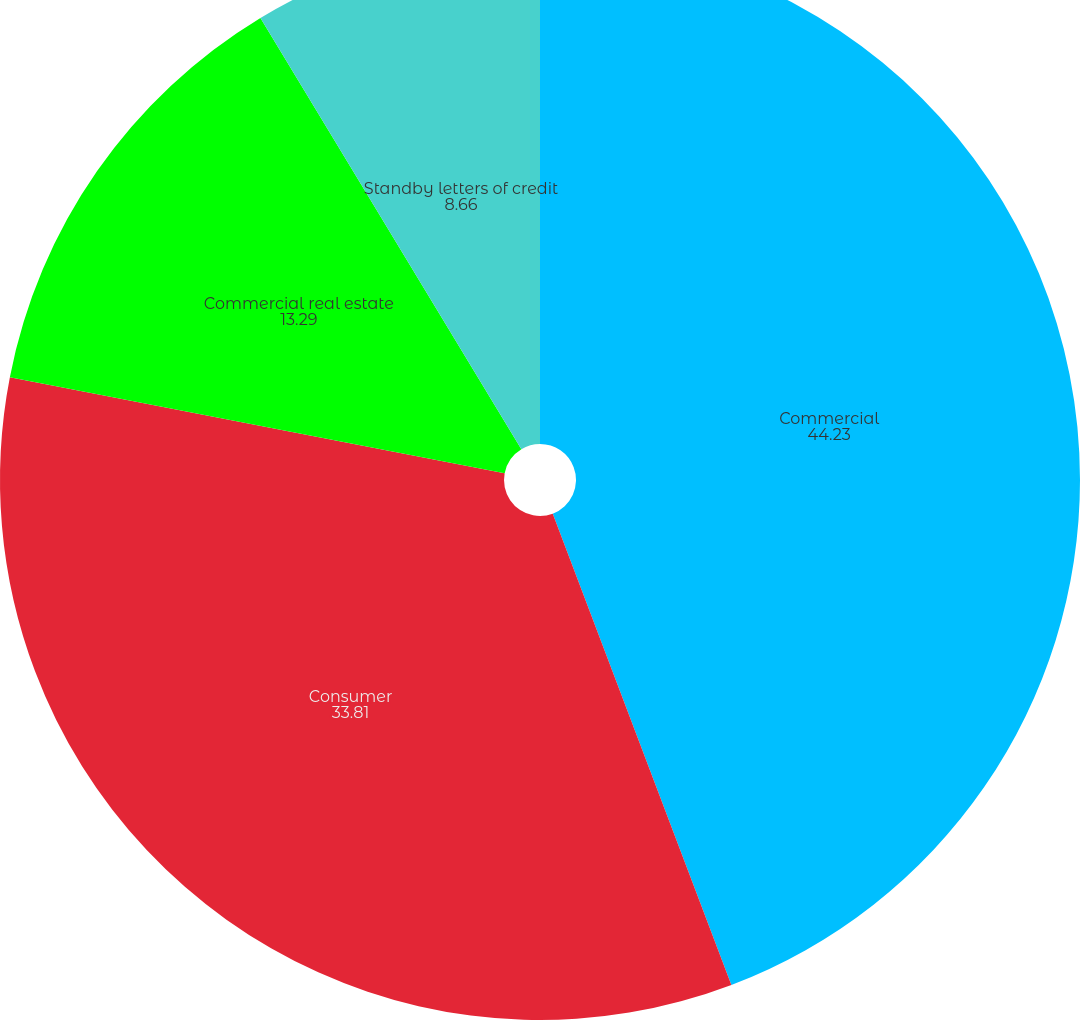<chart> <loc_0><loc_0><loc_500><loc_500><pie_chart><fcel>Commercial<fcel>Consumer<fcel>Commercial real estate<fcel>Standby letters of credit<nl><fcel>44.23%<fcel>33.81%<fcel>13.29%<fcel>8.66%<nl></chart> 